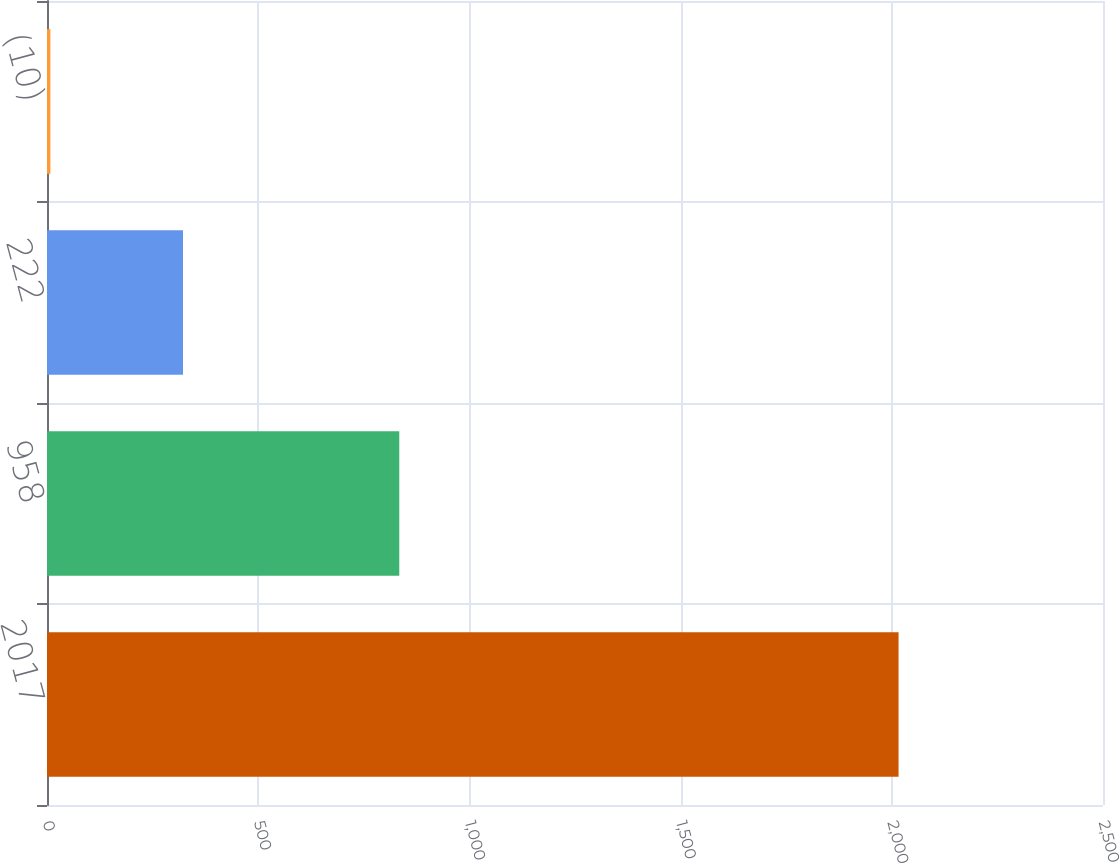<chart> <loc_0><loc_0><loc_500><loc_500><bar_chart><fcel>2017<fcel>958<fcel>222<fcel>(10)<nl><fcel>2016<fcel>834<fcel>322<fcel>8<nl></chart> 